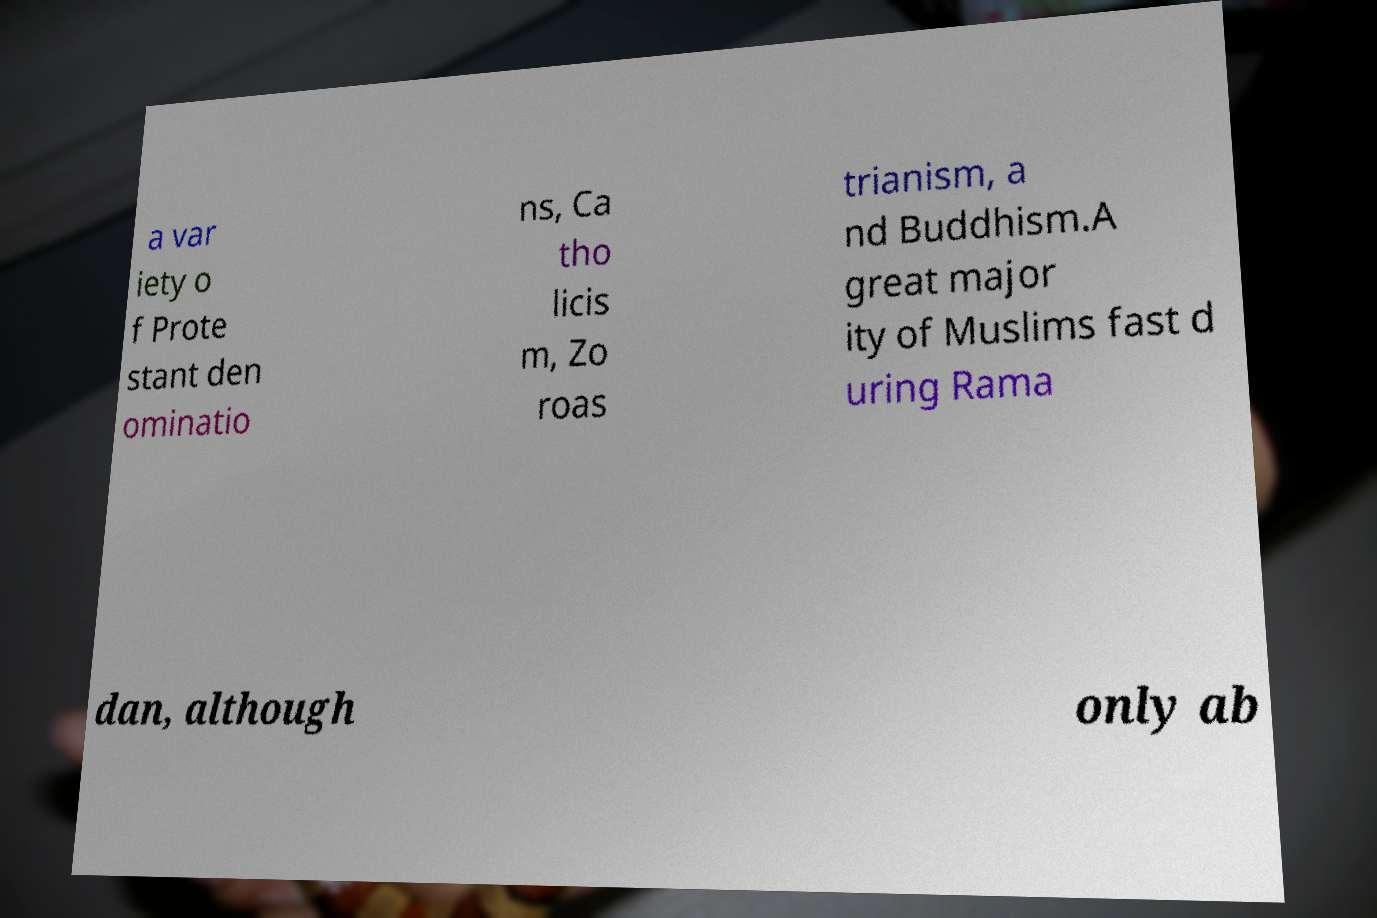Could you assist in decoding the text presented in this image and type it out clearly? a var iety o f Prote stant den ominatio ns, Ca tho licis m, Zo roas trianism, a nd Buddhism.A great major ity of Muslims fast d uring Rama dan, although only ab 